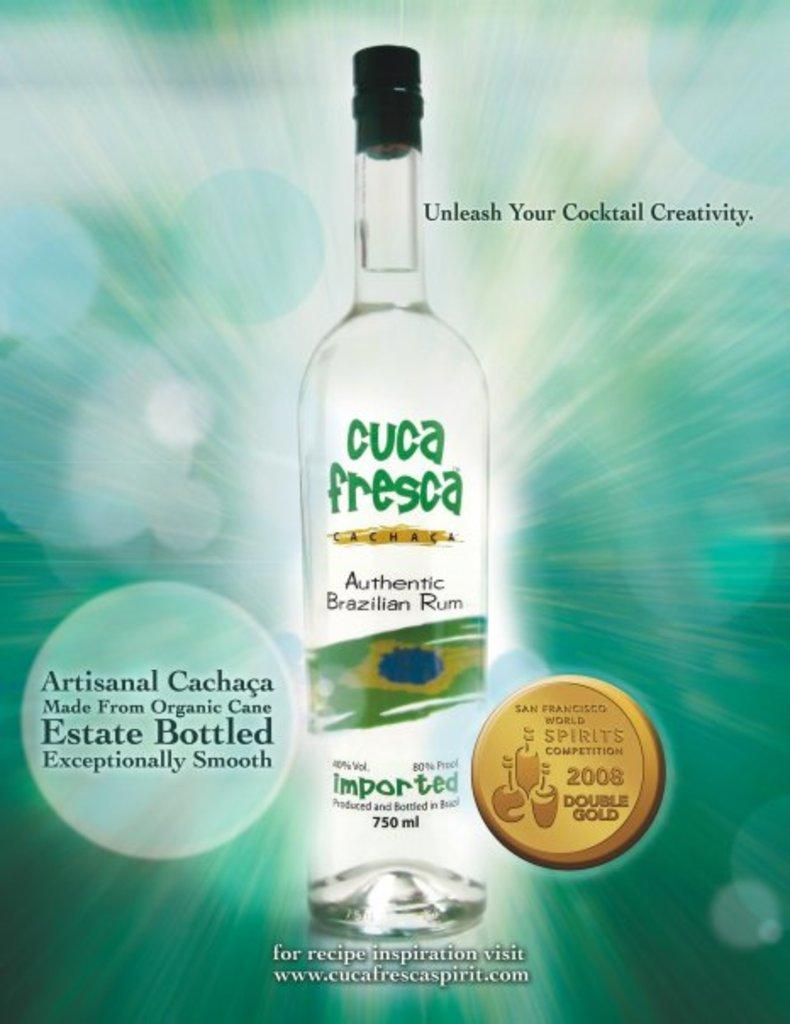Provide a one-sentence caption for the provided image. An advertisement for Cuca Fresca Run with a blue background. 